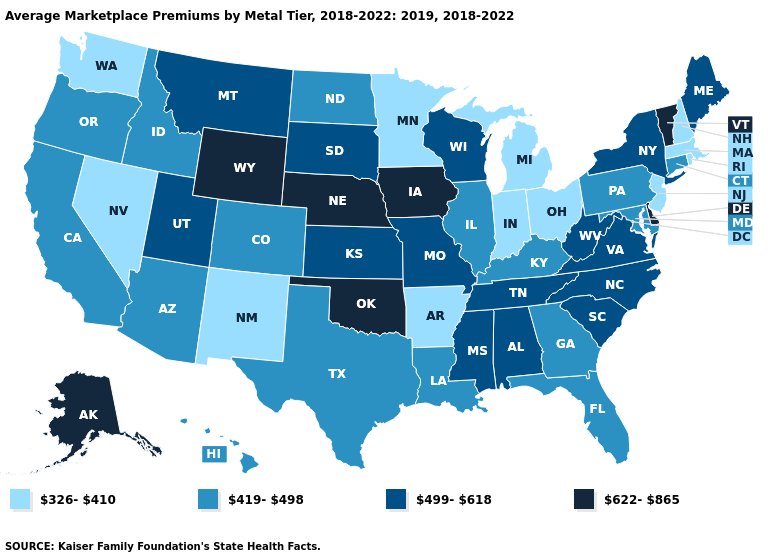Among the states that border Mississippi , which have the lowest value?
Quick response, please. Arkansas. Does Washington have the lowest value in the West?
Be succinct. Yes. What is the value of Texas?
Concise answer only. 419-498. Among the states that border North Carolina , which have the lowest value?
Quick response, please. Georgia. Name the states that have a value in the range 499-618?
Keep it brief. Alabama, Kansas, Maine, Mississippi, Missouri, Montana, New York, North Carolina, South Carolina, South Dakota, Tennessee, Utah, Virginia, West Virginia, Wisconsin. Name the states that have a value in the range 419-498?
Give a very brief answer. Arizona, California, Colorado, Connecticut, Florida, Georgia, Hawaii, Idaho, Illinois, Kentucky, Louisiana, Maryland, North Dakota, Oregon, Pennsylvania, Texas. What is the value of Iowa?
Give a very brief answer. 622-865. What is the value of Washington?
Concise answer only. 326-410. Among the states that border Montana , does North Dakota have the highest value?
Answer briefly. No. What is the lowest value in the MidWest?
Concise answer only. 326-410. What is the value of Mississippi?
Write a very short answer. 499-618. Does New York have the lowest value in the USA?
Quick response, please. No. Which states hav the highest value in the MidWest?
Keep it brief. Iowa, Nebraska. What is the value of Connecticut?
Quick response, please. 419-498. 